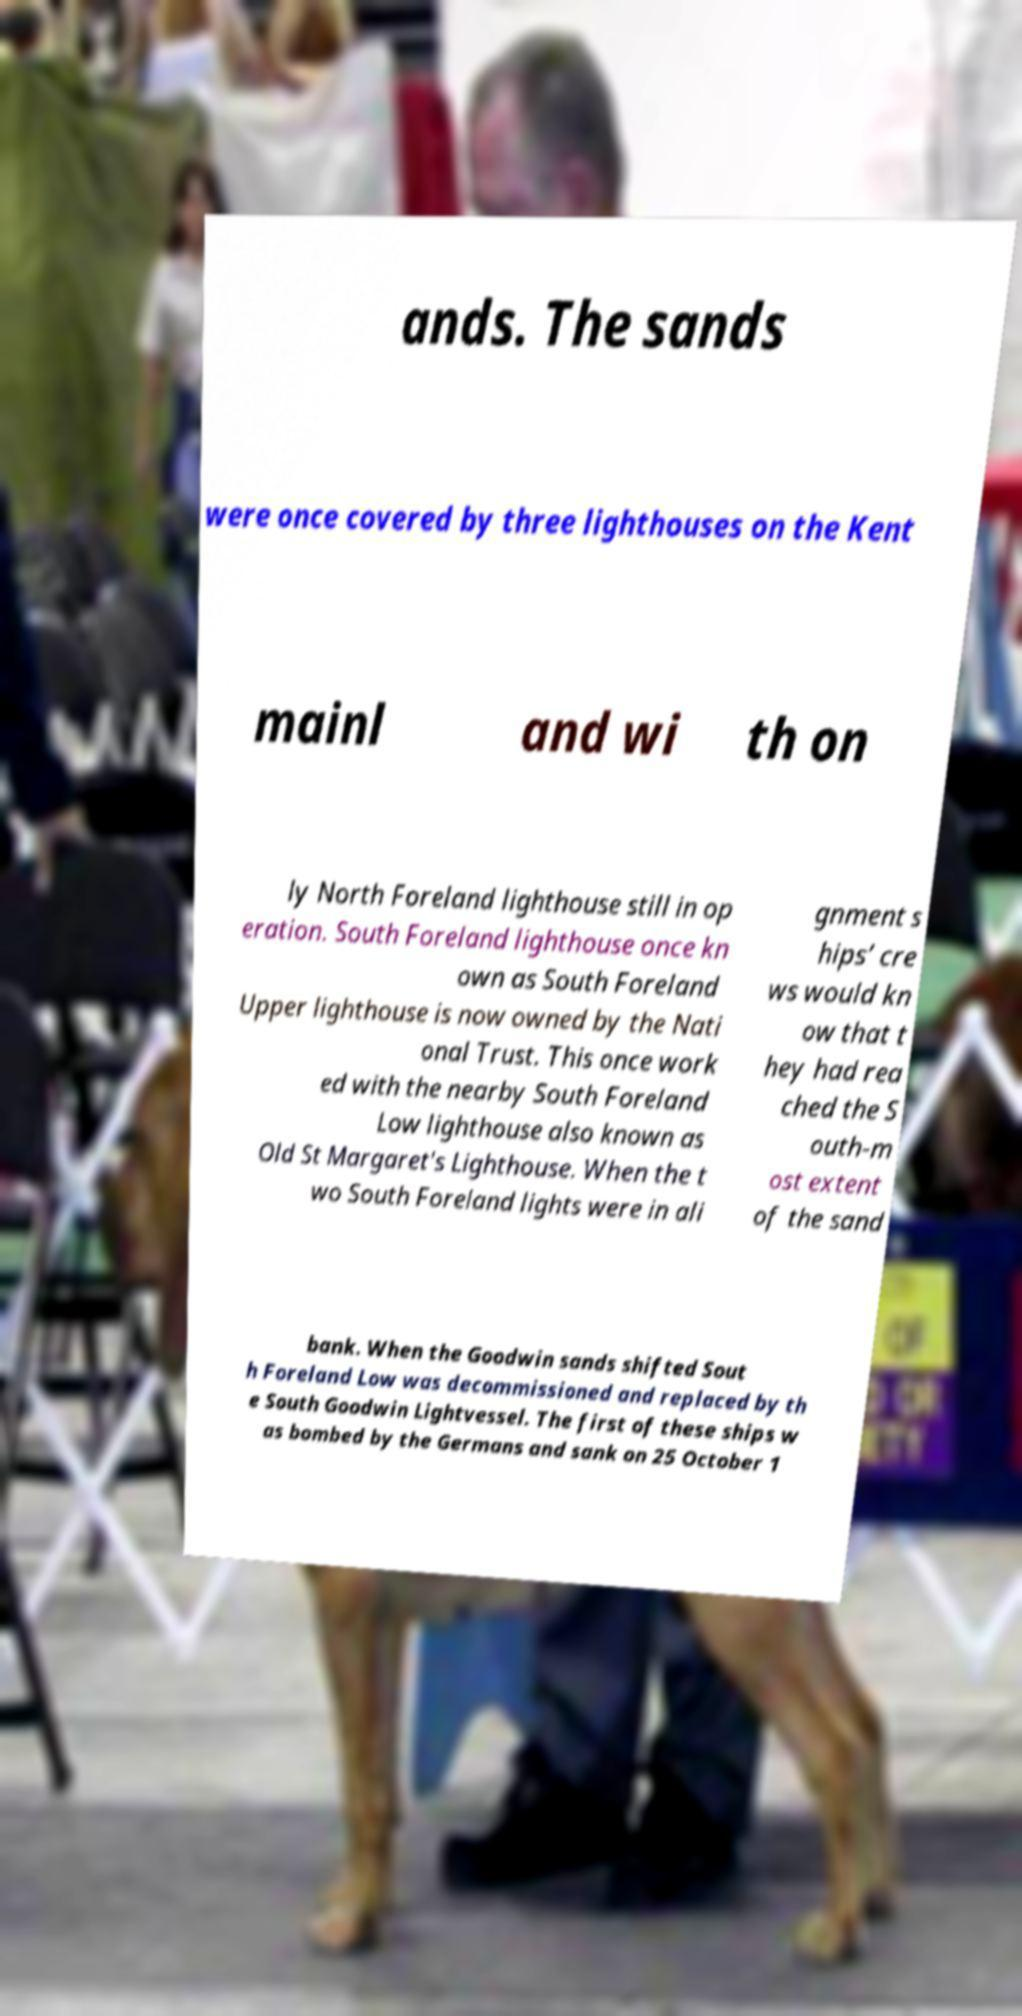I need the written content from this picture converted into text. Can you do that? ands. The sands were once covered by three lighthouses on the Kent mainl and wi th on ly North Foreland lighthouse still in op eration. South Foreland lighthouse once kn own as South Foreland Upper lighthouse is now owned by the Nati onal Trust. This once work ed with the nearby South Foreland Low lighthouse also known as Old St Margaret's Lighthouse. When the t wo South Foreland lights were in ali gnment s hips’ cre ws would kn ow that t hey had rea ched the S outh-m ost extent of the sand bank. When the Goodwin sands shifted Sout h Foreland Low was decommissioned and replaced by th e South Goodwin Lightvessel. The first of these ships w as bombed by the Germans and sank on 25 October 1 